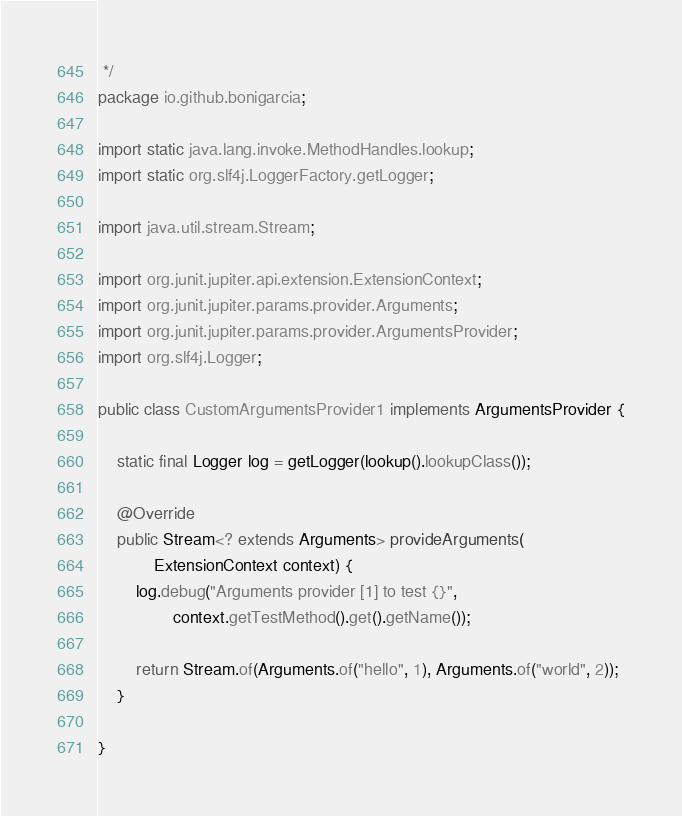Convert code to text. <code><loc_0><loc_0><loc_500><loc_500><_Java_> */
package io.github.bonigarcia;

import static java.lang.invoke.MethodHandles.lookup;
import static org.slf4j.LoggerFactory.getLogger;

import java.util.stream.Stream;

import org.junit.jupiter.api.extension.ExtensionContext;
import org.junit.jupiter.params.provider.Arguments;
import org.junit.jupiter.params.provider.ArgumentsProvider;
import org.slf4j.Logger;

public class CustomArgumentsProvider1 implements ArgumentsProvider {

    static final Logger log = getLogger(lookup().lookupClass());

    @Override
    public Stream<? extends Arguments> provideArguments(
            ExtensionContext context) {
        log.debug("Arguments provider [1] to test {}",
                context.getTestMethod().get().getName());

        return Stream.of(Arguments.of("hello", 1), Arguments.of("world", 2));
    }

}
</code> 